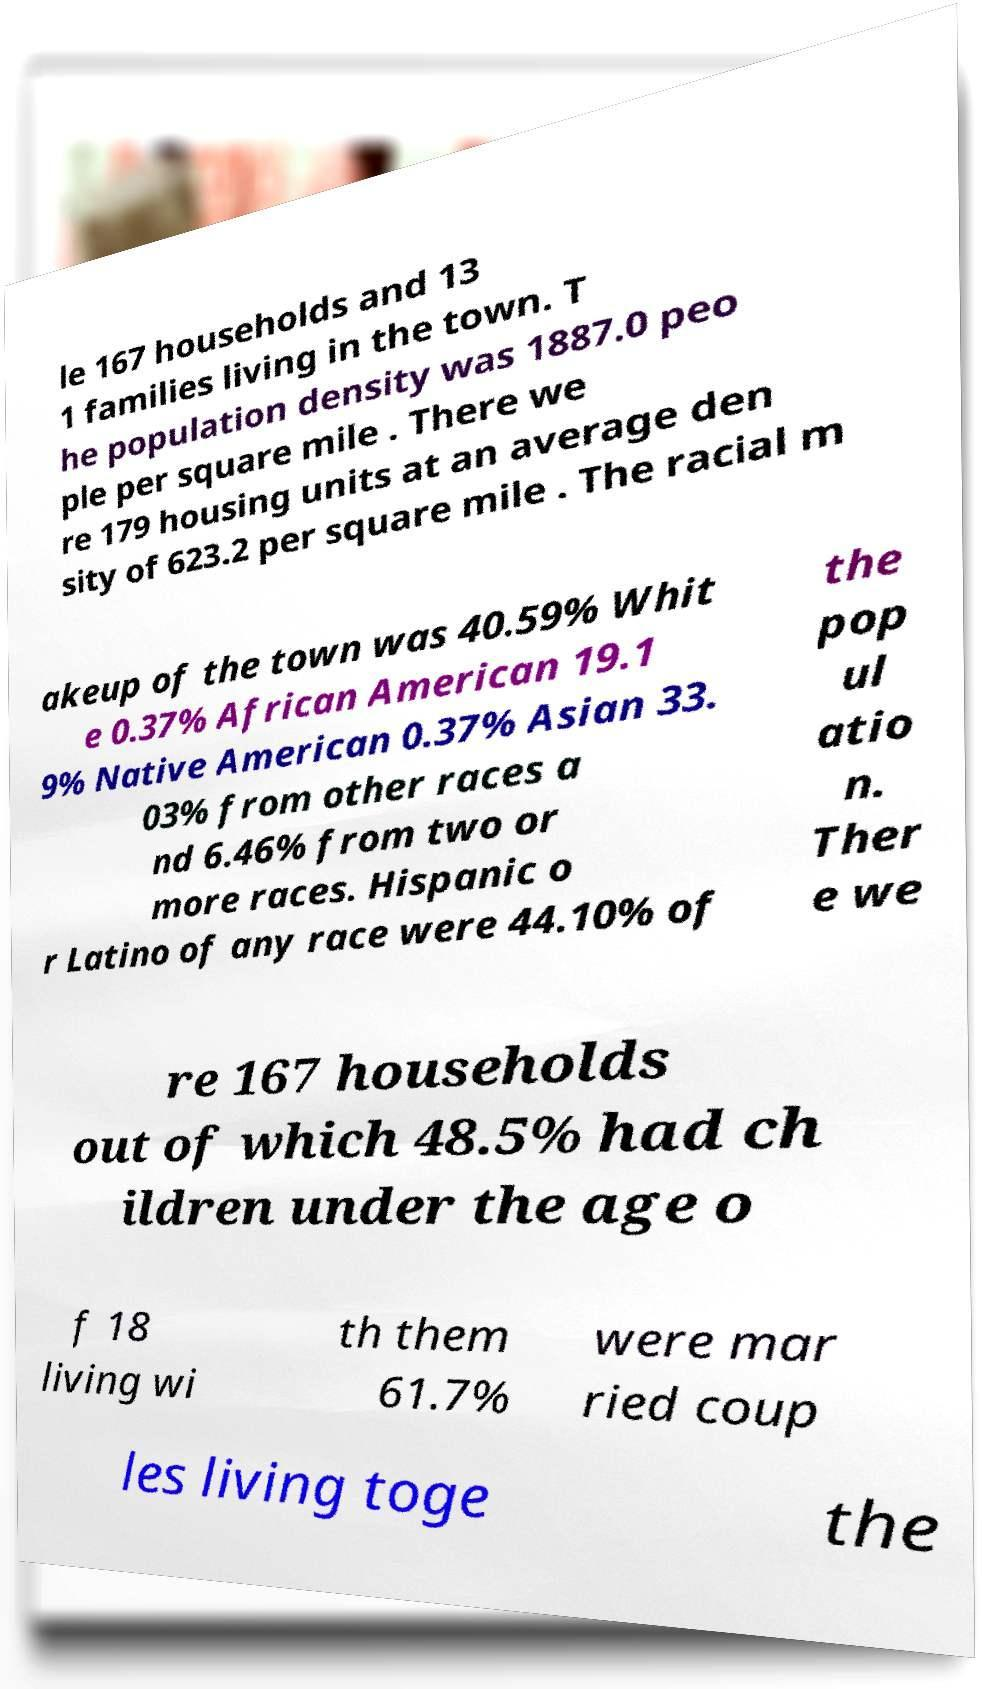Could you extract and type out the text from this image? le 167 households and 13 1 families living in the town. T he population density was 1887.0 peo ple per square mile . There we re 179 housing units at an average den sity of 623.2 per square mile . The racial m akeup of the town was 40.59% Whit e 0.37% African American 19.1 9% Native American 0.37% Asian 33. 03% from other races a nd 6.46% from two or more races. Hispanic o r Latino of any race were 44.10% of the pop ul atio n. Ther e we re 167 households out of which 48.5% had ch ildren under the age o f 18 living wi th them 61.7% were mar ried coup les living toge the 